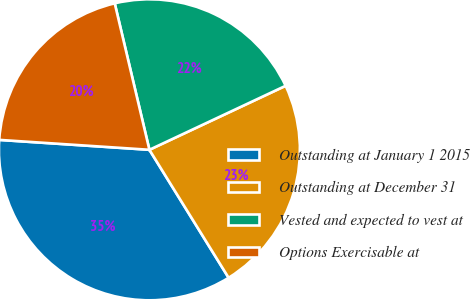<chart> <loc_0><loc_0><loc_500><loc_500><pie_chart><fcel>Outstanding at January 1 2015<fcel>Outstanding at December 31<fcel>Vested and expected to vest at<fcel>Options Exercisable at<nl><fcel>34.87%<fcel>23.17%<fcel>21.71%<fcel>20.25%<nl></chart> 